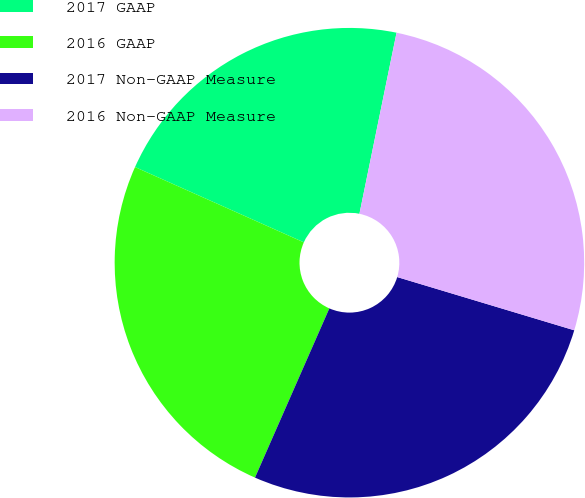Convert chart to OTSL. <chart><loc_0><loc_0><loc_500><loc_500><pie_chart><fcel>2017 GAAP<fcel>2016 GAAP<fcel>2017 Non-GAAP Measure<fcel>2016 Non-GAAP Measure<nl><fcel>21.54%<fcel>25.09%<fcel>26.94%<fcel>26.43%<nl></chart> 